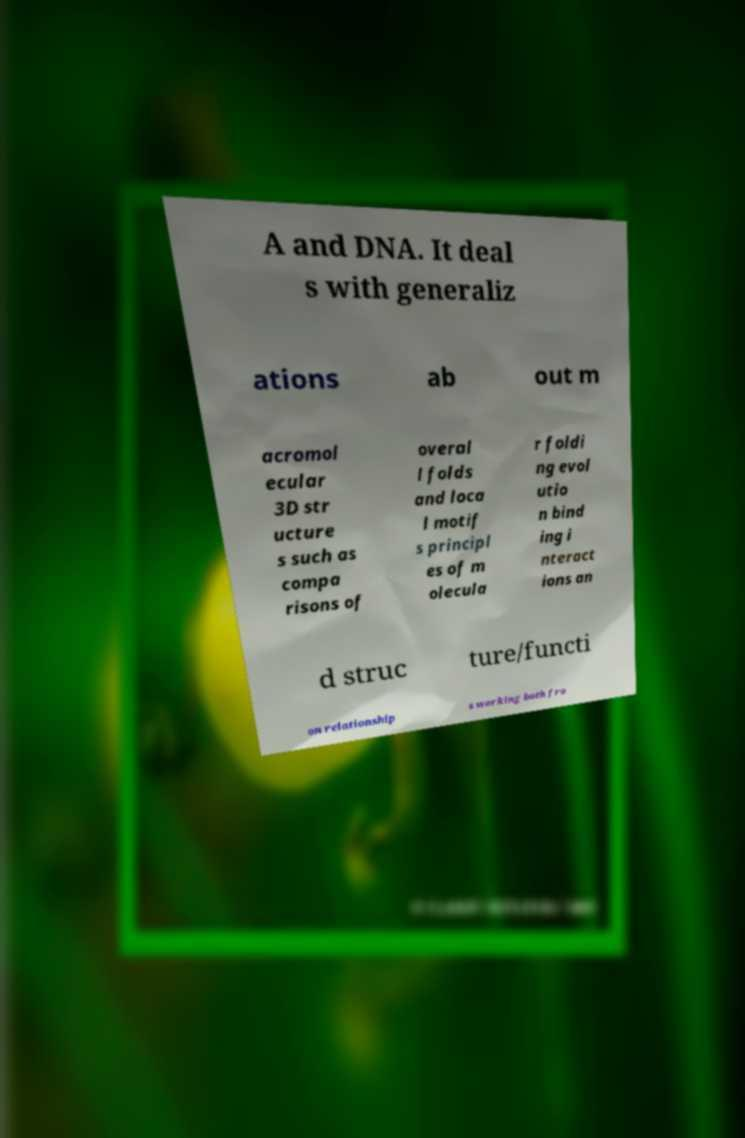Could you assist in decoding the text presented in this image and type it out clearly? A and DNA. It deal s with generaliz ations ab out m acromol ecular 3D str ucture s such as compa risons of overal l folds and loca l motif s principl es of m olecula r foldi ng evol utio n bind ing i nteract ions an d struc ture/functi on relationship s working both fro 